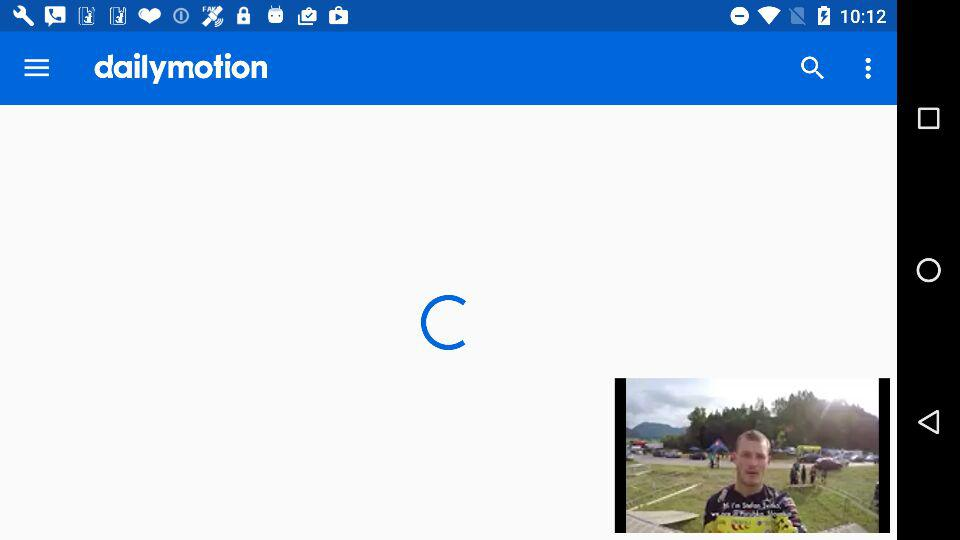Which application can I use for sharing the video? You can use "Facebook", "Google Voice", "idealo Shopping", "Fake GPS - Search location", "Android Beam", "Bluetooth" and "Messaging" for sharing the video. 